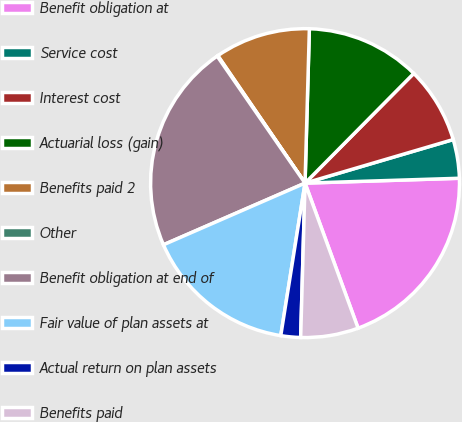Convert chart. <chart><loc_0><loc_0><loc_500><loc_500><pie_chart><fcel>Benefit obligation at<fcel>Service cost<fcel>Interest cost<fcel>Actuarial loss (gain)<fcel>Benefits paid 2<fcel>Other<fcel>Benefit obligation at end of<fcel>Fair value of plan assets at<fcel>Actual return on plan assets<fcel>Benefits paid<nl><fcel>19.92%<fcel>4.05%<fcel>8.02%<fcel>11.98%<fcel>10.0%<fcel>0.08%<fcel>21.9%<fcel>15.95%<fcel>2.06%<fcel>6.03%<nl></chart> 